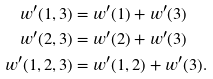<formula> <loc_0><loc_0><loc_500><loc_500>w ^ { \prime } ( 1 , 3 ) & = w ^ { \prime } ( 1 ) + w ^ { \prime } ( 3 ) \\ w ^ { \prime } ( 2 , 3 ) & = w ^ { \prime } ( 2 ) + w ^ { \prime } ( 3 ) \\ w ^ { \prime } ( 1 , 2 , 3 ) & = w ^ { \prime } ( 1 , 2 ) + w ^ { \prime } ( 3 ) .</formula> 